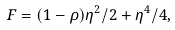Convert formula to latex. <formula><loc_0><loc_0><loc_500><loc_500>F = ( 1 - \rho ) \eta ^ { 2 } / 2 + \eta ^ { 4 } / 4 ,</formula> 